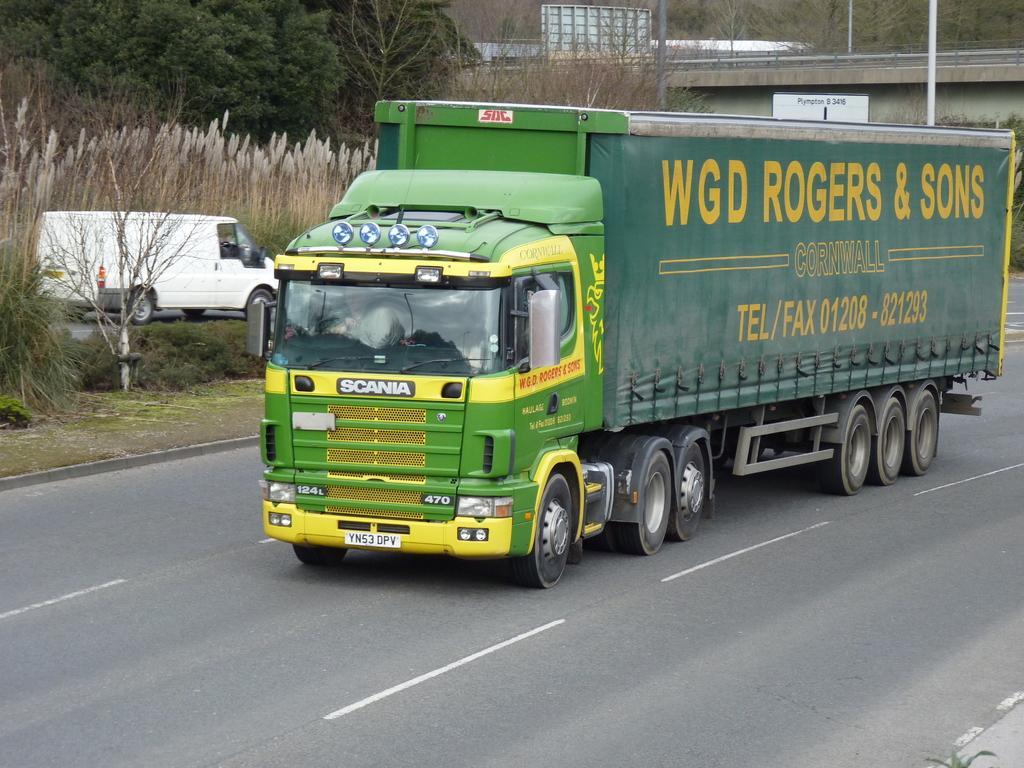How would you summarize this image in a sentence or two? In the center of the image we can see truck on the road. On the left there is a van. In the background there are trees, bridge and poles. 